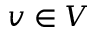<formula> <loc_0><loc_0><loc_500><loc_500>v \in V</formula> 